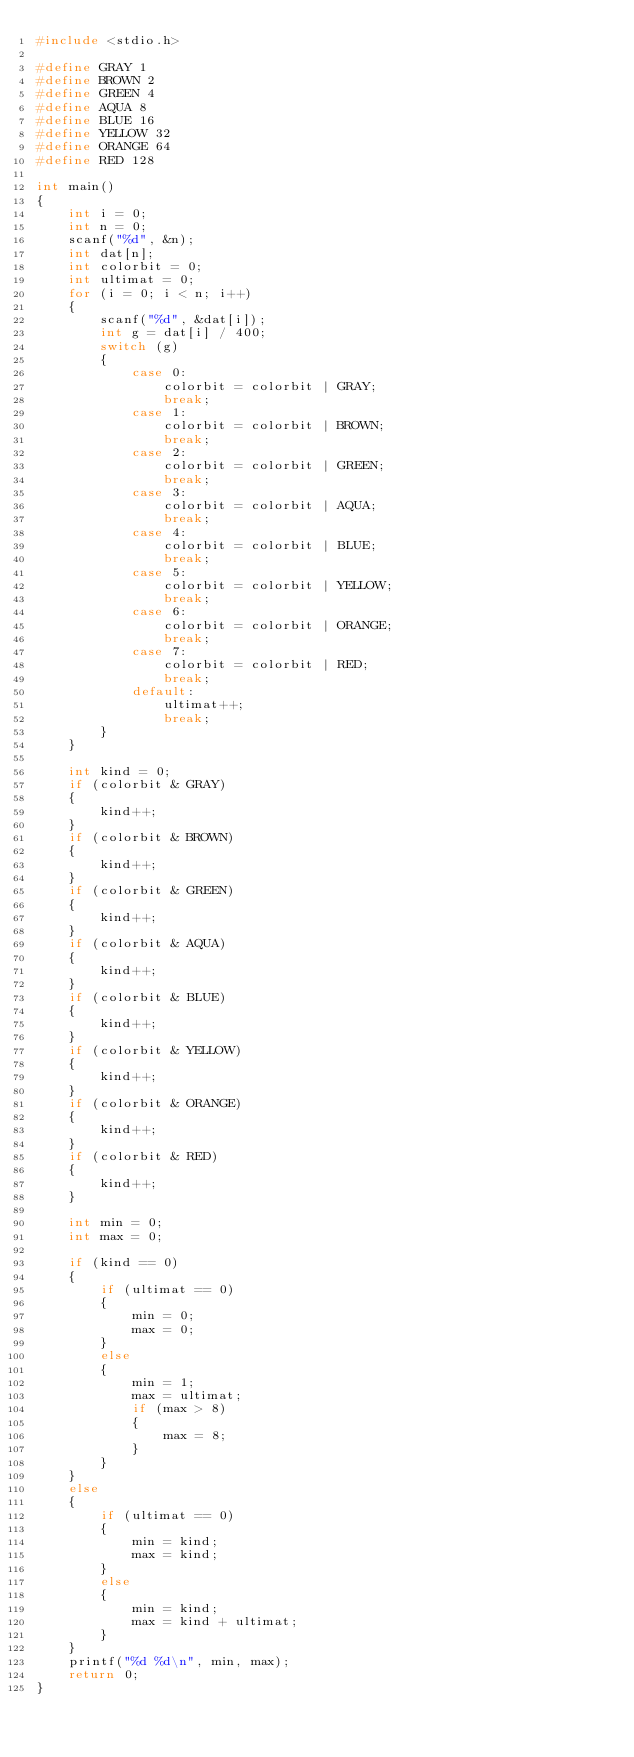<code> <loc_0><loc_0><loc_500><loc_500><_C_>#include <stdio.h>

#define GRAY 1
#define BROWN 2
#define GREEN 4
#define AQUA 8
#define BLUE 16
#define YELLOW 32
#define ORANGE 64
#define RED 128

int main()
{
    int i = 0;
    int n = 0;
    scanf("%d", &n);
    int dat[n];
    int colorbit = 0;
    int ultimat = 0;
    for (i = 0; i < n; i++)
    {
        scanf("%d", &dat[i]);
        int g = dat[i] / 400;
        switch (g)
        {
            case 0:
                colorbit = colorbit | GRAY;
                break;
            case 1:
                colorbit = colorbit | BROWN;
                break;
            case 2:
                colorbit = colorbit | GREEN;
                break;
            case 3:
                colorbit = colorbit | AQUA;
                break;
            case 4:
                colorbit = colorbit | BLUE;
                break;
            case 5:
                colorbit = colorbit | YELLOW;
                break;
            case 6:
                colorbit = colorbit | ORANGE;
                break;
            case 7:
                colorbit = colorbit | RED;
                break;
            default:
                ultimat++;
                break;
        }
    }

    int kind = 0;
    if (colorbit & GRAY)
    {
        kind++;
    }
    if (colorbit & BROWN)
    {
        kind++;
    }
    if (colorbit & GREEN)
    {
        kind++;
    }
    if (colorbit & AQUA)
    {
        kind++;
    }
    if (colorbit & BLUE)
    {
        kind++;
    }
    if (colorbit & YELLOW)
    {
        kind++;
    }
    if (colorbit & ORANGE)
    {
        kind++;
    }
    if (colorbit & RED)
    {
        kind++;
    }

    int min = 0;
    int max = 0;

    if (kind == 0)
    {
        if (ultimat == 0)
        {
            min = 0;
            max = 0;
        }
        else
        {
            min = 1;
            max = ultimat;
            if (max > 8)
            {
                max = 8;
            }
        }
    }
    else
    {
        if (ultimat == 0)
        {
            min = kind;
            max = kind;
        }
        else
        {
            min = kind;
            max = kind + ultimat;
        }
    }
    printf("%d %d\n", min, max);
    return 0;
}
</code> 